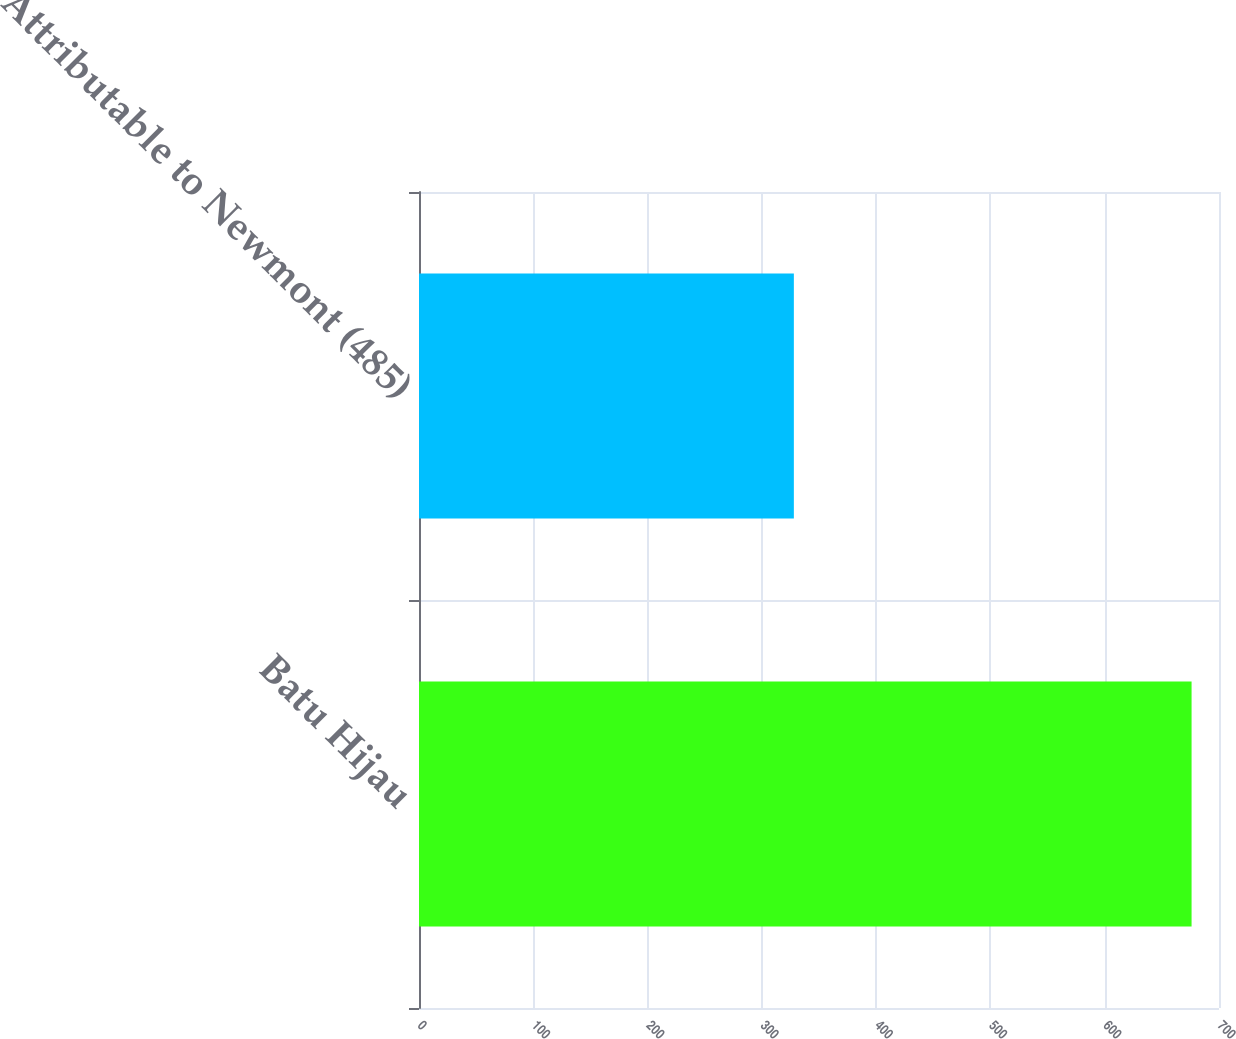Convert chart. <chart><loc_0><loc_0><loc_500><loc_500><bar_chart><fcel>Batu Hijau<fcel>Attributable to Newmont (485)<nl><fcel>676<fcel>328<nl></chart> 